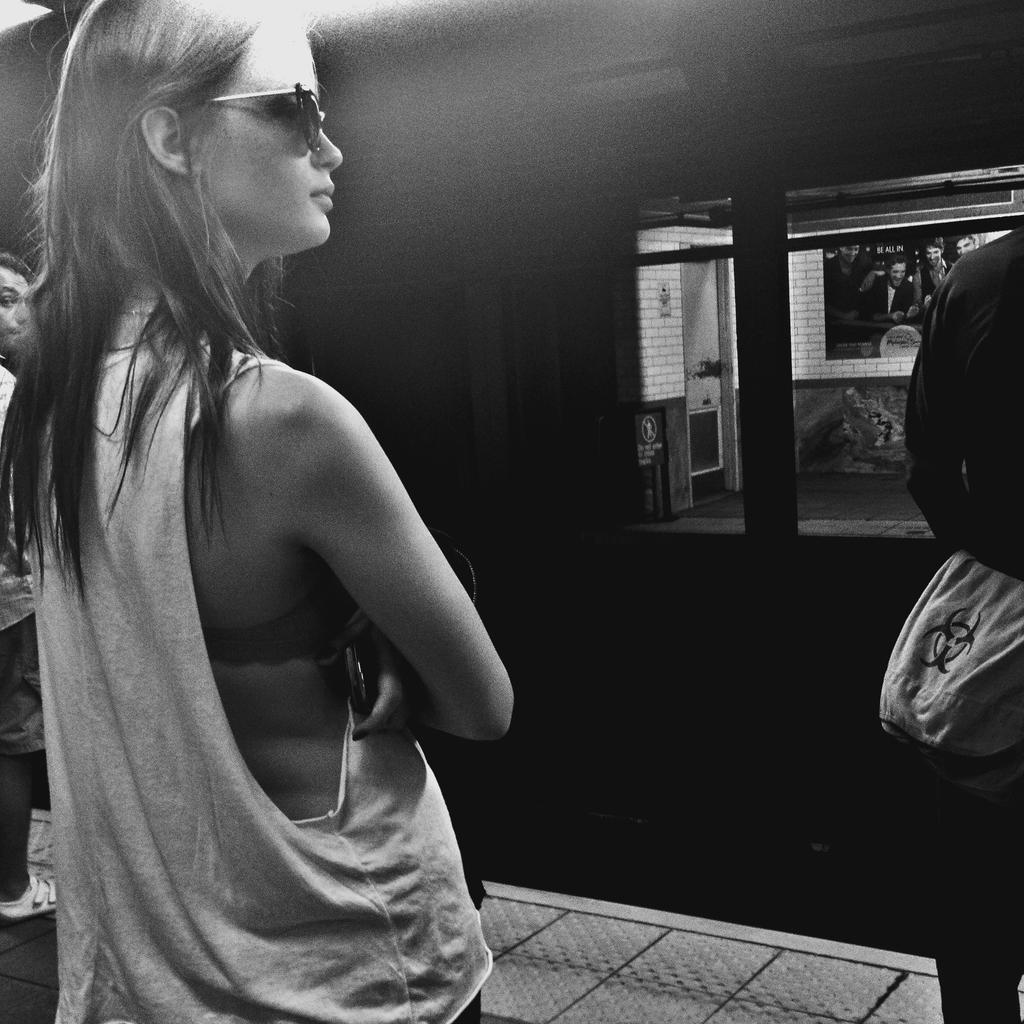What is happening in the image? There are people standing in the image. Where are the people located in the image? The people are in the middle of the image. What is in front of the people? There is a locomotive in front of the people. What type of skirt is the locomotive wearing in the image? The locomotive is not a person and therefore cannot wear a skirt. 